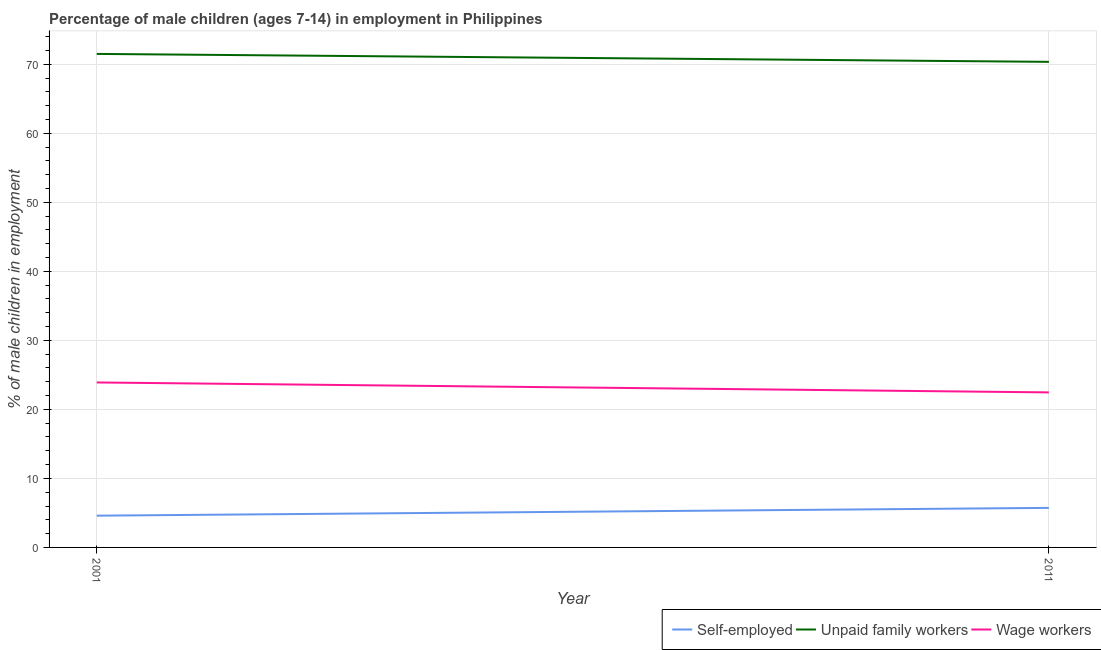Does the line corresponding to percentage of children employed as unpaid family workers intersect with the line corresponding to percentage of children employed as wage workers?
Provide a succinct answer. No. Is the number of lines equal to the number of legend labels?
Provide a succinct answer. Yes. What is the percentage of children employed as unpaid family workers in 2011?
Make the answer very short. 70.35. Across all years, what is the maximum percentage of self employed children?
Offer a terse response. 5.73. Across all years, what is the minimum percentage of self employed children?
Your answer should be very brief. 4.6. In which year was the percentage of self employed children minimum?
Make the answer very short. 2001. What is the total percentage of children employed as unpaid family workers in the graph?
Ensure brevity in your answer.  141.85. What is the difference between the percentage of children employed as wage workers in 2001 and that in 2011?
Give a very brief answer. 1.44. What is the difference between the percentage of children employed as unpaid family workers in 2011 and the percentage of self employed children in 2001?
Offer a terse response. 65.75. What is the average percentage of children employed as wage workers per year?
Provide a short and direct response. 23.18. In the year 2001, what is the difference between the percentage of children employed as unpaid family workers and percentage of children employed as wage workers?
Give a very brief answer. 47.6. What is the ratio of the percentage of self employed children in 2001 to that in 2011?
Ensure brevity in your answer.  0.8. In how many years, is the percentage of self employed children greater than the average percentage of self employed children taken over all years?
Make the answer very short. 1. Is it the case that in every year, the sum of the percentage of self employed children and percentage of children employed as unpaid family workers is greater than the percentage of children employed as wage workers?
Make the answer very short. Yes. Is the percentage of children employed as unpaid family workers strictly less than the percentage of children employed as wage workers over the years?
Your answer should be compact. No. How many years are there in the graph?
Ensure brevity in your answer.  2. Does the graph contain any zero values?
Provide a succinct answer. No. Does the graph contain grids?
Your answer should be compact. Yes. What is the title of the graph?
Provide a succinct answer. Percentage of male children (ages 7-14) in employment in Philippines. What is the label or title of the Y-axis?
Offer a terse response. % of male children in employment. What is the % of male children in employment in Unpaid family workers in 2001?
Ensure brevity in your answer.  71.5. What is the % of male children in employment of Wage workers in 2001?
Offer a terse response. 23.9. What is the % of male children in employment in Self-employed in 2011?
Your response must be concise. 5.73. What is the % of male children in employment in Unpaid family workers in 2011?
Offer a terse response. 70.35. What is the % of male children in employment in Wage workers in 2011?
Offer a terse response. 22.46. Across all years, what is the maximum % of male children in employment in Self-employed?
Ensure brevity in your answer.  5.73. Across all years, what is the maximum % of male children in employment of Unpaid family workers?
Provide a succinct answer. 71.5. Across all years, what is the maximum % of male children in employment of Wage workers?
Offer a very short reply. 23.9. Across all years, what is the minimum % of male children in employment of Self-employed?
Ensure brevity in your answer.  4.6. Across all years, what is the minimum % of male children in employment of Unpaid family workers?
Provide a short and direct response. 70.35. Across all years, what is the minimum % of male children in employment in Wage workers?
Keep it short and to the point. 22.46. What is the total % of male children in employment in Self-employed in the graph?
Your response must be concise. 10.33. What is the total % of male children in employment of Unpaid family workers in the graph?
Provide a short and direct response. 141.85. What is the total % of male children in employment of Wage workers in the graph?
Ensure brevity in your answer.  46.36. What is the difference between the % of male children in employment in Self-employed in 2001 and that in 2011?
Keep it short and to the point. -1.13. What is the difference between the % of male children in employment of Unpaid family workers in 2001 and that in 2011?
Provide a succinct answer. 1.15. What is the difference between the % of male children in employment of Wage workers in 2001 and that in 2011?
Keep it short and to the point. 1.44. What is the difference between the % of male children in employment in Self-employed in 2001 and the % of male children in employment in Unpaid family workers in 2011?
Keep it short and to the point. -65.75. What is the difference between the % of male children in employment in Self-employed in 2001 and the % of male children in employment in Wage workers in 2011?
Ensure brevity in your answer.  -17.86. What is the difference between the % of male children in employment in Unpaid family workers in 2001 and the % of male children in employment in Wage workers in 2011?
Your response must be concise. 49.04. What is the average % of male children in employment of Self-employed per year?
Ensure brevity in your answer.  5.17. What is the average % of male children in employment in Unpaid family workers per year?
Keep it short and to the point. 70.92. What is the average % of male children in employment in Wage workers per year?
Your response must be concise. 23.18. In the year 2001, what is the difference between the % of male children in employment in Self-employed and % of male children in employment in Unpaid family workers?
Your answer should be very brief. -66.9. In the year 2001, what is the difference between the % of male children in employment in Self-employed and % of male children in employment in Wage workers?
Keep it short and to the point. -19.3. In the year 2001, what is the difference between the % of male children in employment of Unpaid family workers and % of male children in employment of Wage workers?
Provide a short and direct response. 47.6. In the year 2011, what is the difference between the % of male children in employment in Self-employed and % of male children in employment in Unpaid family workers?
Offer a terse response. -64.62. In the year 2011, what is the difference between the % of male children in employment of Self-employed and % of male children in employment of Wage workers?
Give a very brief answer. -16.73. In the year 2011, what is the difference between the % of male children in employment of Unpaid family workers and % of male children in employment of Wage workers?
Your answer should be very brief. 47.89. What is the ratio of the % of male children in employment in Self-employed in 2001 to that in 2011?
Keep it short and to the point. 0.8. What is the ratio of the % of male children in employment of Unpaid family workers in 2001 to that in 2011?
Provide a short and direct response. 1.02. What is the ratio of the % of male children in employment in Wage workers in 2001 to that in 2011?
Provide a succinct answer. 1.06. What is the difference between the highest and the second highest % of male children in employment in Self-employed?
Your response must be concise. 1.13. What is the difference between the highest and the second highest % of male children in employment of Unpaid family workers?
Ensure brevity in your answer.  1.15. What is the difference between the highest and the second highest % of male children in employment of Wage workers?
Offer a very short reply. 1.44. What is the difference between the highest and the lowest % of male children in employment in Self-employed?
Offer a very short reply. 1.13. What is the difference between the highest and the lowest % of male children in employment in Unpaid family workers?
Provide a short and direct response. 1.15. What is the difference between the highest and the lowest % of male children in employment in Wage workers?
Offer a very short reply. 1.44. 